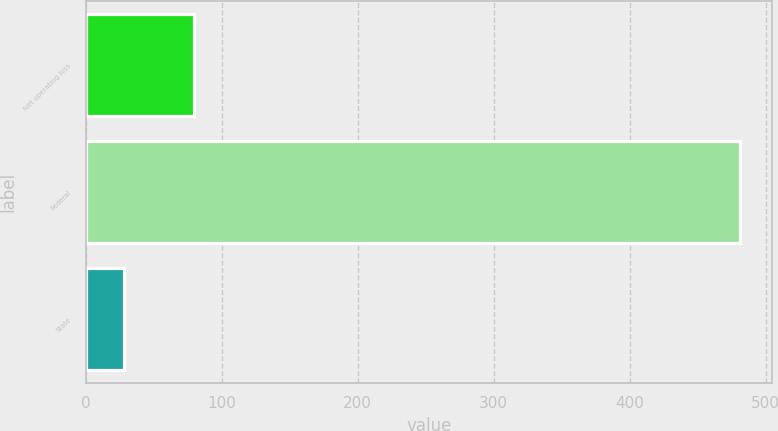<chart> <loc_0><loc_0><loc_500><loc_500><bar_chart><fcel>Net operating loss<fcel>Federal<fcel>State<nl><fcel>80<fcel>481<fcel>28<nl></chart> 